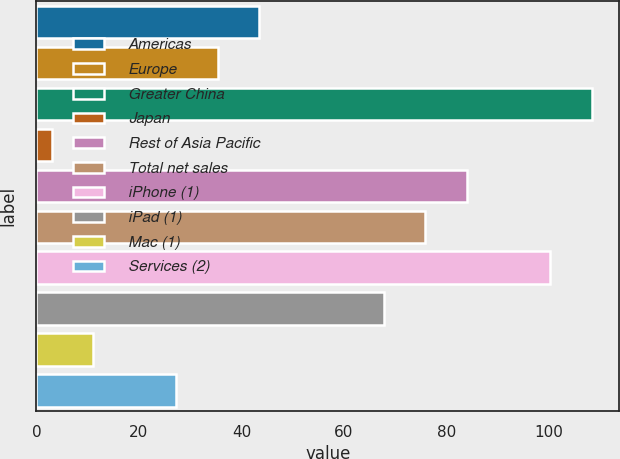<chart> <loc_0><loc_0><loc_500><loc_500><bar_chart><fcel>Americas<fcel>Europe<fcel>Greater China<fcel>Japan<fcel>Rest of Asia Pacific<fcel>Total net sales<fcel>iPhone (1)<fcel>iPad (1)<fcel>Mac (1)<fcel>Services (2)<nl><fcel>43.5<fcel>35.4<fcel>108.3<fcel>3<fcel>84<fcel>75.9<fcel>100.2<fcel>67.8<fcel>11.1<fcel>27.3<nl></chart> 